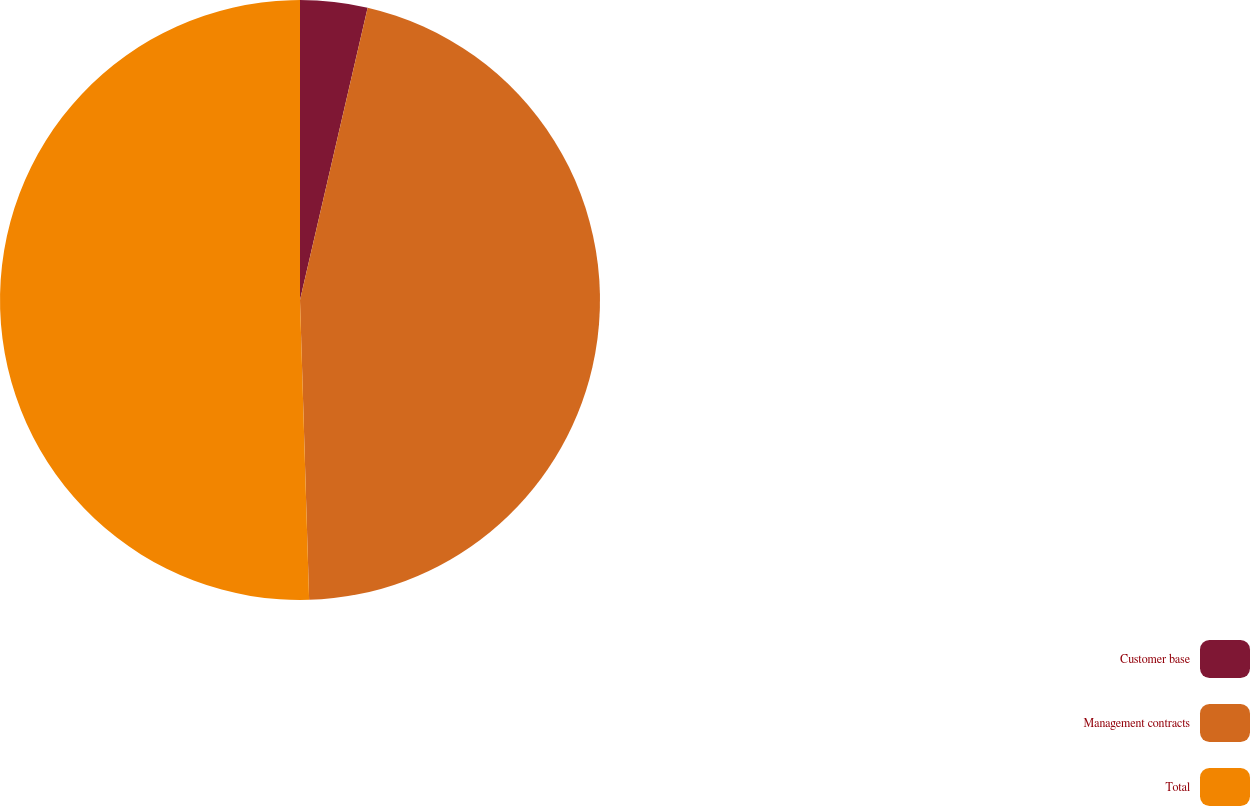<chart> <loc_0><loc_0><loc_500><loc_500><pie_chart><fcel>Customer base<fcel>Management contracts<fcel>Total<nl><fcel>3.62%<fcel>45.9%<fcel>50.49%<nl></chart> 